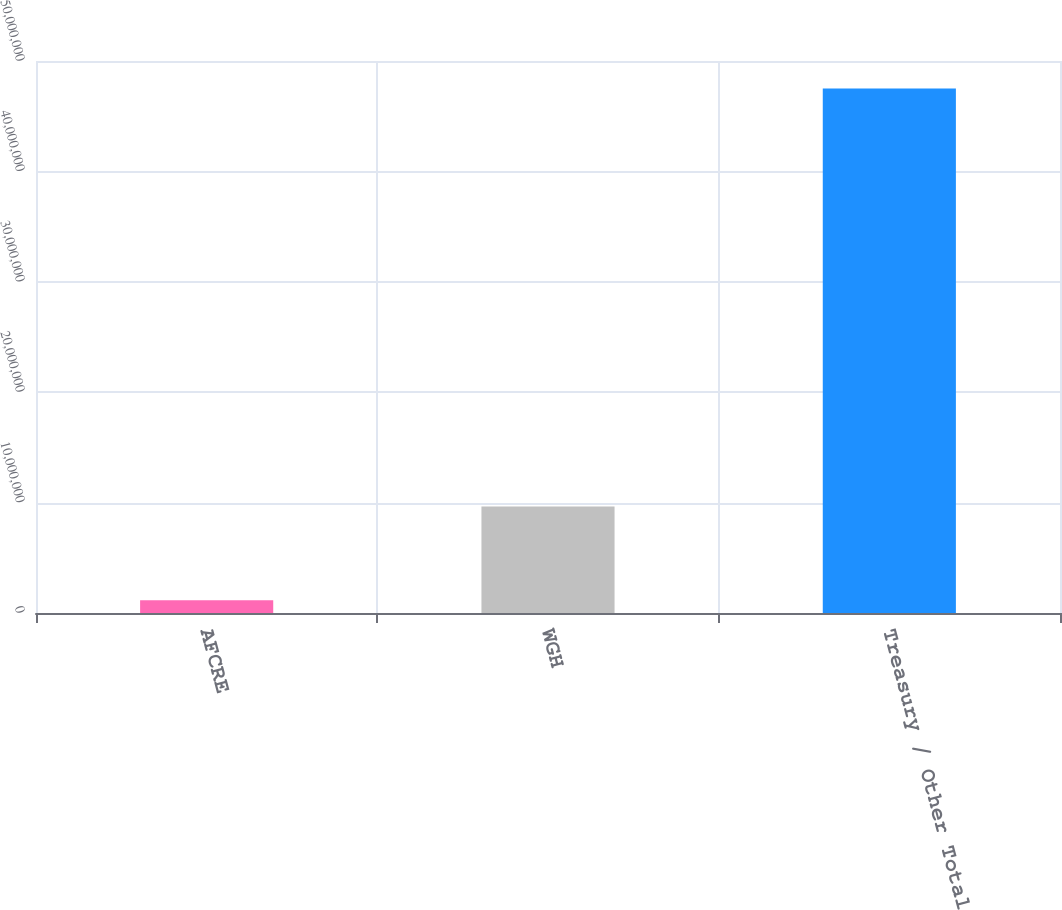Convert chart. <chart><loc_0><loc_0><loc_500><loc_500><bar_chart><fcel>AFCRE<fcel>WGH<fcel>Treasury / Other Total<nl><fcel>1.16364e+06<fcel>9.65717e+06<fcel>4.75067e+07<nl></chart> 